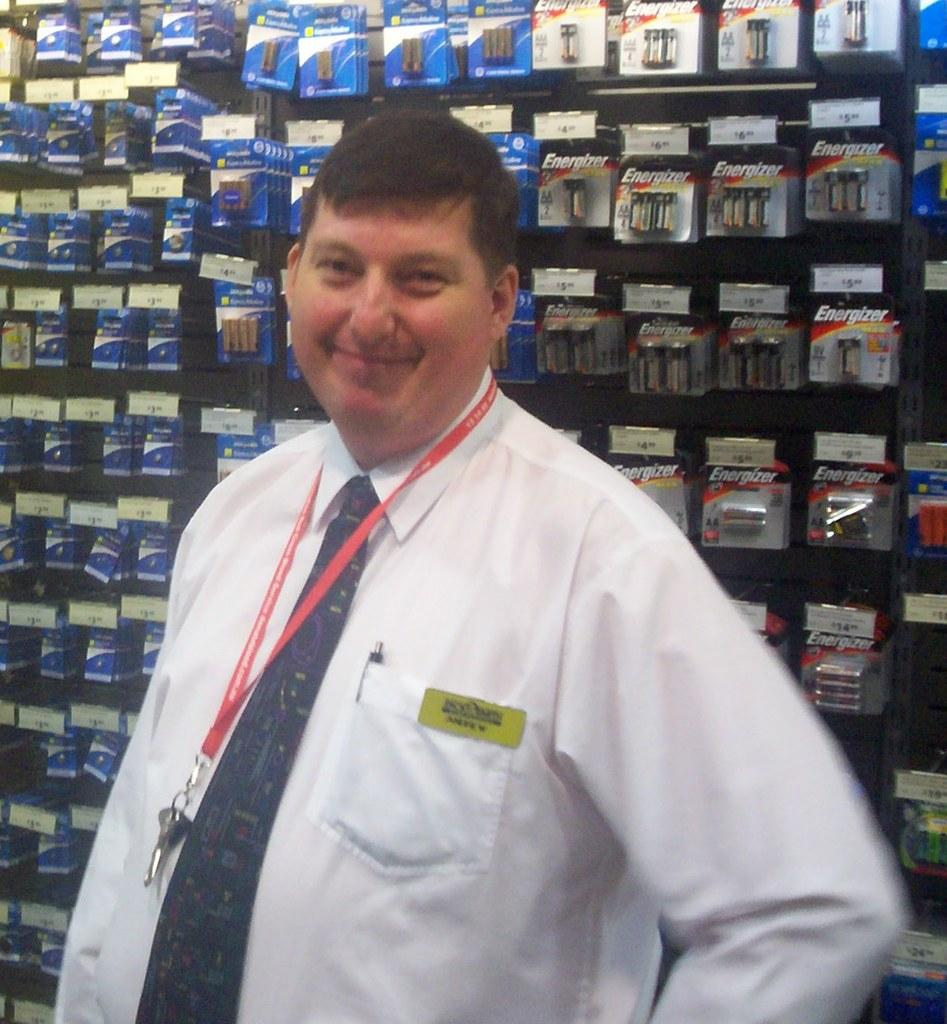<image>
Share a concise interpretation of the image provided. The worker stands in front of a stand of batteries including the brand Energizer. 